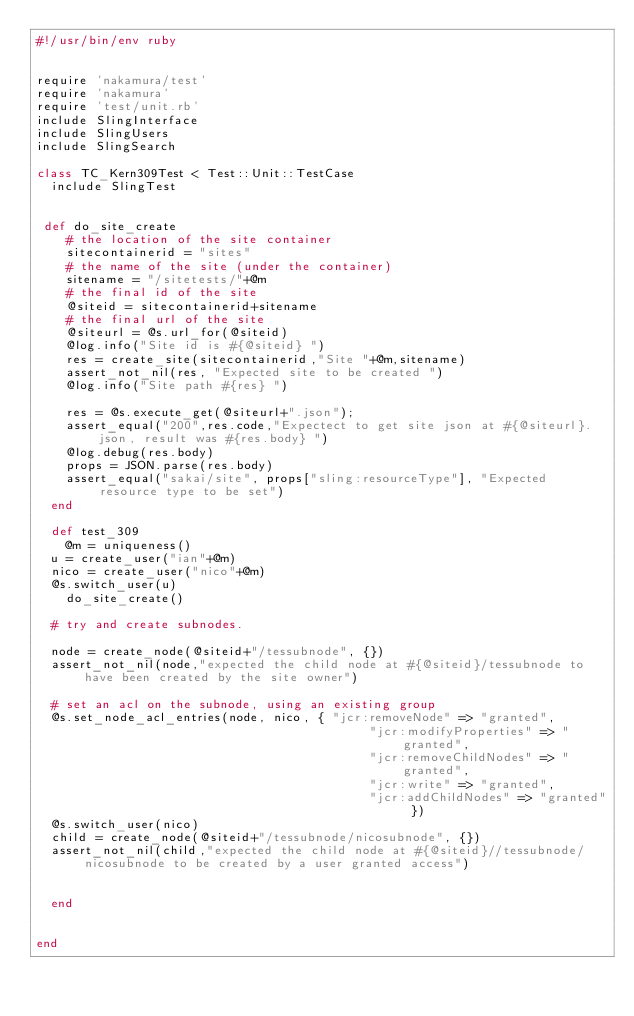<code> <loc_0><loc_0><loc_500><loc_500><_Ruby_>#!/usr/bin/env ruby


require 'nakamura/test'
require 'nakamura'
require 'test/unit.rb'
include SlingInterface
include SlingUsers
include SlingSearch

class TC_Kern309Test < Test::Unit::TestCase
  include SlingTest


 def do_site_create
    # the location of the site container
    sitecontainerid = "sites"
    # the name of the site (under the container)
    sitename = "/sitetests/"+@m
    # the final id of the site
    @siteid = sitecontainerid+sitename
    # the final url of the site
    @siteurl = @s.url_for(@siteid)
    @log.info("Site id is #{@siteid} ")
    res = create_site(sitecontainerid,"Site "+@m,sitename)
    assert_not_nil(res, "Expected site to be created ")
    @log.info("Site path #{res} ")

    res = @s.execute_get(@siteurl+".json");
    assert_equal("200",res.code,"Expectect to get site json at #{@siteurl}.json, result was #{res.body} ")
    @log.debug(res.body)
    props = JSON.parse(res.body)
    assert_equal("sakai/site", props["sling:resourceType"], "Expected resource type to be set")
  end

  def test_309
    @m = uniqueness()
	u = create_user("ian"+@m)
	nico = create_user("nico"+@m)
	@s.switch_user(u)
    do_site_create()

	# try and create subnodes.

	node = create_node(@siteid+"/tessubnode", {})
	assert_not_nil(node,"expected the child node at #{@siteid}/tessubnode to have been created by the site owner")

	# set an acl on the subnode, using an existing group
	@s.set_node_acl_entries(node, nico, { "jcr:removeNode" => "granted",
                                             "jcr:modifyProperties" => "granted",
                                             "jcr:removeChildNodes" => "granted",
                                             "jcr:write" => "granted",
                                             "jcr:addChildNodes" => "granted" })
	@s.switch_user(nico)
	child = create_node(@siteid+"/tessubnode/nicosubnode", {})
	assert_not_nil(child,"expected the child node at #{@siteid}//tessubnode/nicosubnode to be created by a user granted access")


  end


end
</code> 